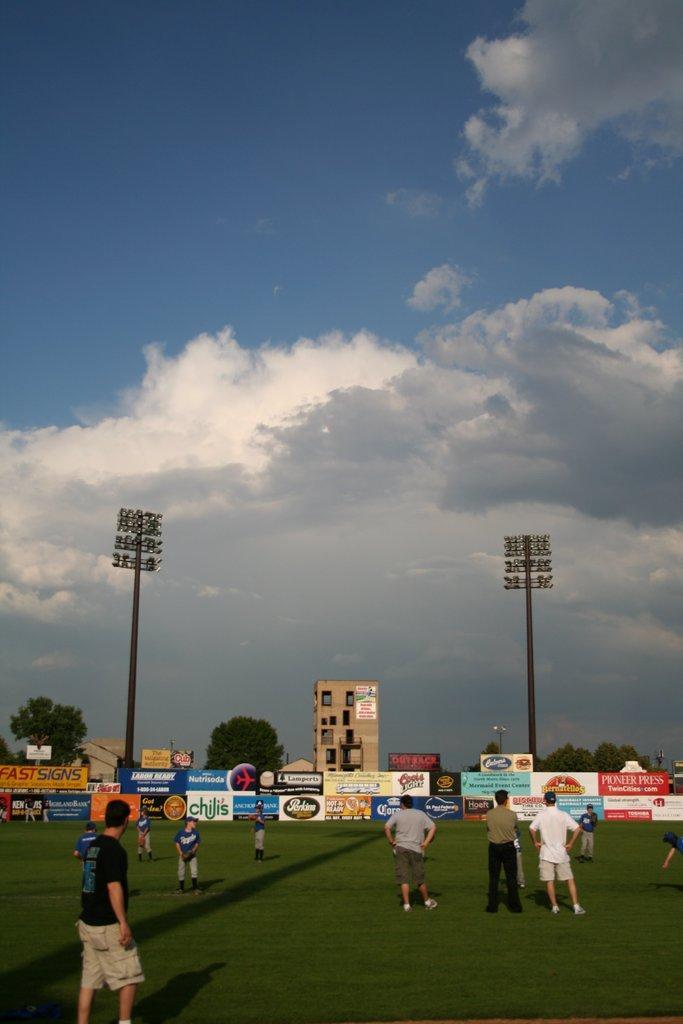Can you describe this image briefly? In this picture I can see a group of people are standing on the ground. In the background I can see building, trees, lights and sky. I can also see boards. 